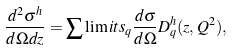<formula> <loc_0><loc_0><loc_500><loc_500>\frac { d ^ { 2 } \sigma ^ { h } } { d \Omega d z } = \sum \lim i t s _ { q } \frac { d \sigma } { d \Omega } D _ { q } ^ { h } ( z , Q ^ { 2 } ) ,</formula> 